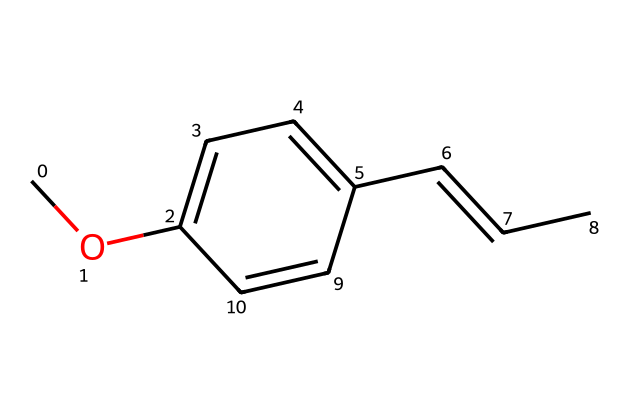How many carbon atoms are in anethole? By examining the molecular structure represented by the SMILES, we can count the carbon atoms present. The structure shows a total of eleven carbon atoms in the aromatic ring and the aliphatic chain.
Answer: eleven What functional group is present in anethole? Anethole includes an ether functional group due to the presence of the -O- atom connecting two carbon chains, which is characteristic of ethers.
Answer: ether What type of bond connects the oxygen atom to the carbon atoms in anethole? The bond connecting the oxygen to the carbons in the ether functional group is a single covalent bond, as indicated by the structure where oxygen is shown connecting to two carbon atoms.
Answer: single bond Does anethole contain any double bonds? Yes, the structure contains a double bond as evidenced by the "/C=C/" part in the SMILES, which indicates a carbon-carbon double bond in the aliphatic chain.
Answer: yes What is the molecular formula of anethole? By interpreting the SMILES and counting the hydrogen atoms, we can derive the molecular formula. The total atom count gives us the formula C11H12O.
Answer: C11H12O How many rings are present in anethole? The structure consists of one aromatic ring (the benzene-like structure) observed in the depiction of the compound, making it a monocyclic structure.
Answer: one 